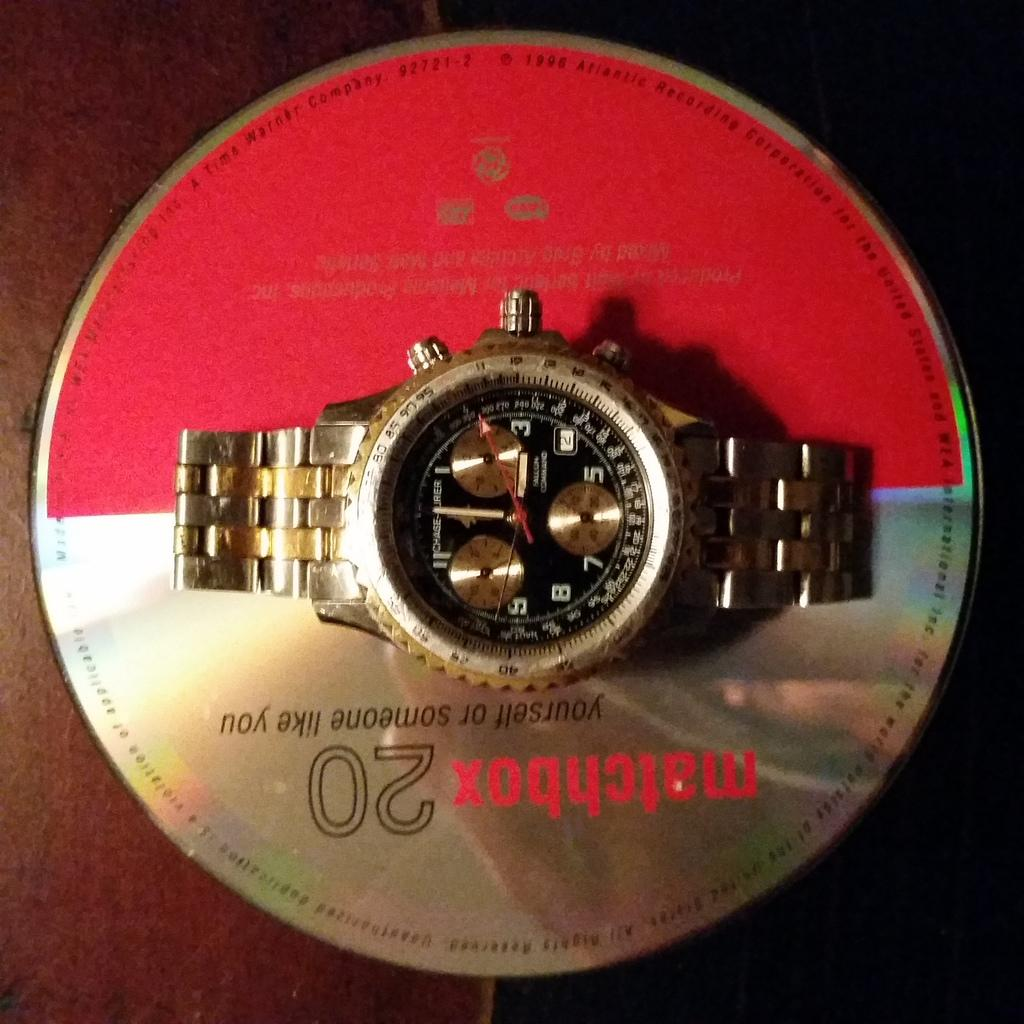<image>
Create a compact narrative representing the image presented. a watch displayed on a red and silver cd saying matchbox 20 